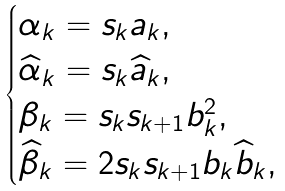Convert formula to latex. <formula><loc_0><loc_0><loc_500><loc_500>\begin{cases} \alpha _ { k } = s _ { k } a _ { k } , \\ \widehat { \alpha } _ { k } = s _ { k } \widehat { a } _ { k } , \\ \beta _ { k } = s _ { k } s _ { k + 1 } b _ { k } ^ { 2 } , \\ \widehat { \beta } _ { k } = 2 s _ { k } s _ { k + 1 } b _ { k } \widehat { b } _ { k } , \end{cases}</formula> 